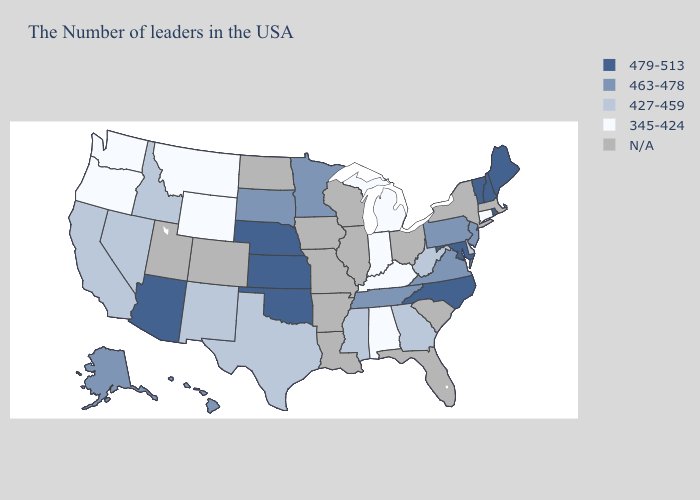Is the legend a continuous bar?
Concise answer only. No. Does the map have missing data?
Short answer required. Yes. Does Rhode Island have the highest value in the USA?
Be succinct. Yes. What is the value of Michigan?
Give a very brief answer. 345-424. Does the first symbol in the legend represent the smallest category?
Be succinct. No. What is the value of Alaska?
Answer briefly. 463-478. What is the value of Arizona?
Short answer required. 479-513. What is the value of Kentucky?
Write a very short answer. 345-424. Does the map have missing data?
Short answer required. Yes. Name the states that have a value in the range 463-478?
Keep it brief. New Jersey, Pennsylvania, Virginia, Tennessee, Minnesota, South Dakota, Alaska, Hawaii. What is the lowest value in states that border Idaho?
Keep it brief. 345-424. 